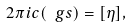Convert formula to latex. <formula><loc_0><loc_0><loc_500><loc_500>2 \pi i c ( \ g s ) = [ \eta ] ,</formula> 